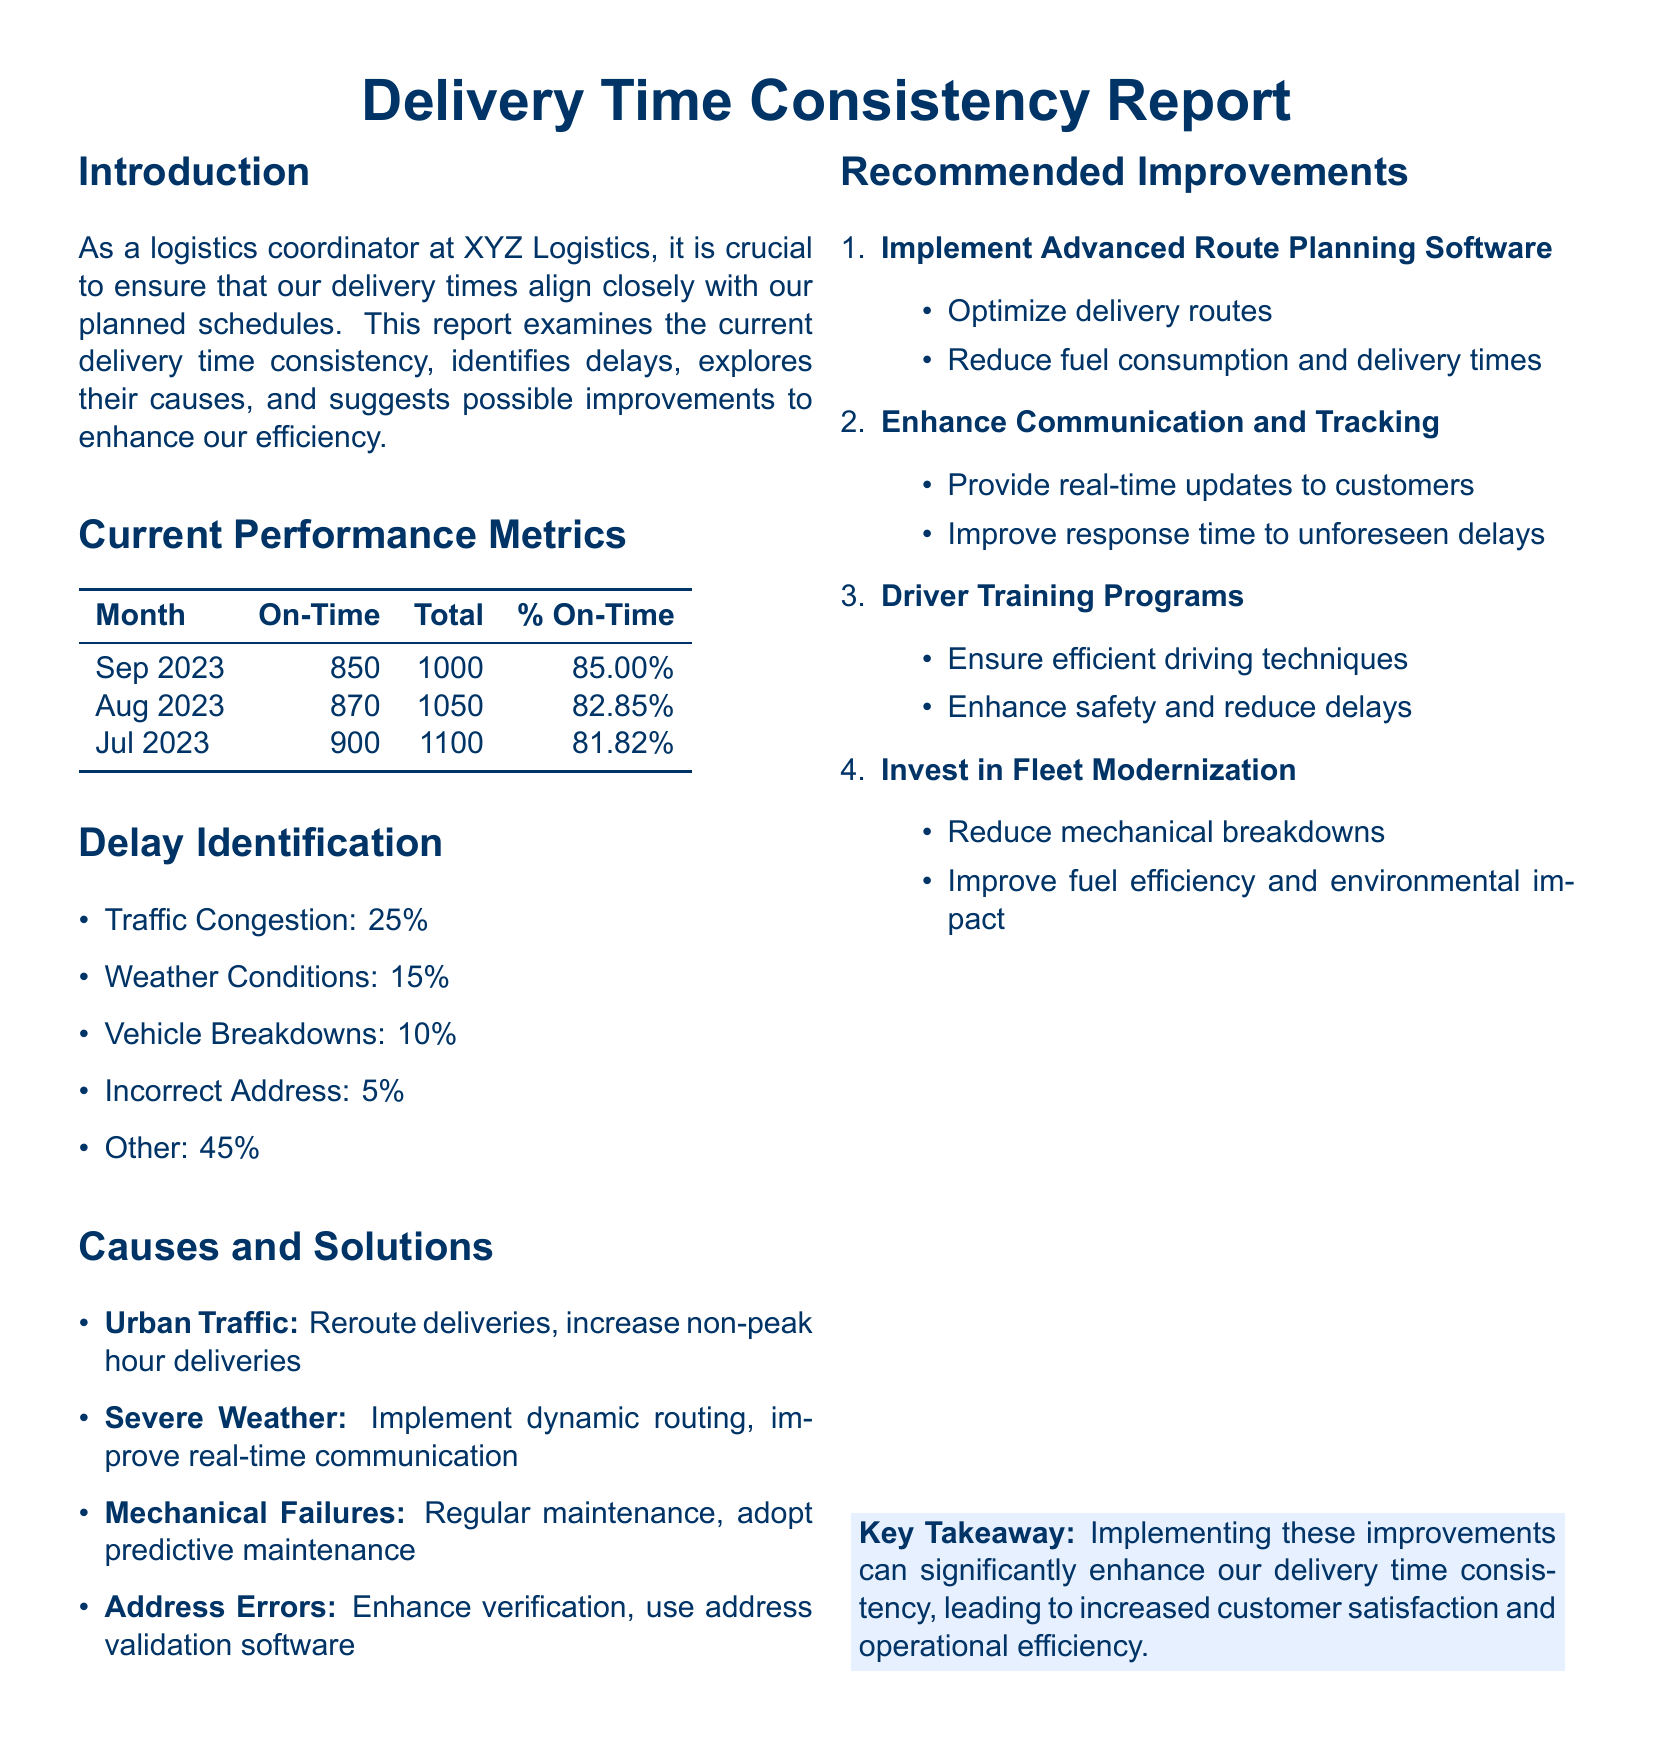What was the on-time delivery percentage for September 2023? The on-time delivery percentage is stated in the Current Performance Metrics section for September 2023 as 85.00%.
Answer: 85.00% What are the primary causes of delays? The delay causes are listed in the Delay Identification section, detailing the percentages attributed to each cause.
Answer: Traffic Congestion, Weather Conditions, Vehicle Breakdowns, Incorrect Address, Other What was the total number of deliveries in August 2023? The total number of deliveries for August 2023 is listed in the Current Performance Metrics table.
Answer: 1050 What specific improvement suggests to reduce mechanical failures? The Causes and Solutions section includes solutions for mechanical failures and mentions regular maintenance.
Answer: Regular maintenance What is the percentage of delays caused by traffic congestion? The percentage is provided in the Delay Identification section as part of the causes of delays.
Answer: 25% What delivery improvement focuses on communication with customers? The Recommended Improvements section suggests enhancing communication and tracking to improve customer interactions.
Answer: Enhance Communication and Tracking Which month had the highest on-time percentage? The Current Performance Metrics table shows the on-time percentages for each month, allowing for comparison.
Answer: September 2023 What aspect of fleet management is suggested to reduce mechanical breakdowns? The Recommended Improvements section discusses fleet modernization as a strategy to mitigate breakdowns.
Answer: Fleet Modernization 